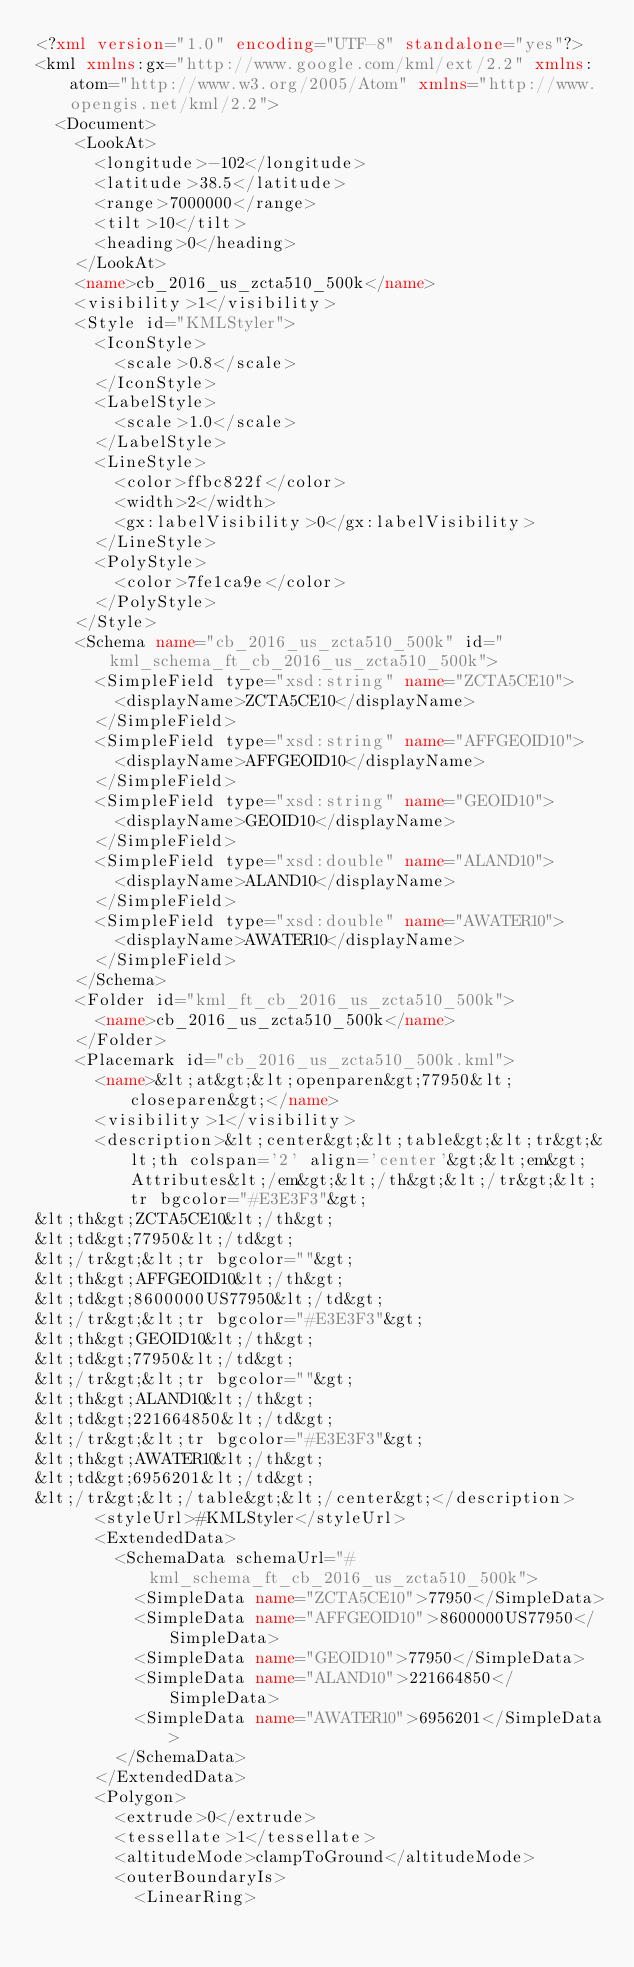Convert code to text. <code><loc_0><loc_0><loc_500><loc_500><_XML_><?xml version="1.0" encoding="UTF-8" standalone="yes"?>
<kml xmlns:gx="http://www.google.com/kml/ext/2.2" xmlns:atom="http://www.w3.org/2005/Atom" xmlns="http://www.opengis.net/kml/2.2">
  <Document>
    <LookAt>
      <longitude>-102</longitude>
      <latitude>38.5</latitude>
      <range>7000000</range>
      <tilt>10</tilt>
      <heading>0</heading>
    </LookAt>
    <name>cb_2016_us_zcta510_500k</name>
    <visibility>1</visibility>
    <Style id="KMLStyler">
      <IconStyle>
        <scale>0.8</scale>
      </IconStyle>
      <LabelStyle>
        <scale>1.0</scale>
      </LabelStyle>
      <LineStyle>
        <color>ffbc822f</color>
        <width>2</width>
        <gx:labelVisibility>0</gx:labelVisibility>
      </LineStyle>
      <PolyStyle>
        <color>7fe1ca9e</color>
      </PolyStyle>
    </Style>
    <Schema name="cb_2016_us_zcta510_500k" id="kml_schema_ft_cb_2016_us_zcta510_500k">
      <SimpleField type="xsd:string" name="ZCTA5CE10">
        <displayName>ZCTA5CE10</displayName>
      </SimpleField>
      <SimpleField type="xsd:string" name="AFFGEOID10">
        <displayName>AFFGEOID10</displayName>
      </SimpleField>
      <SimpleField type="xsd:string" name="GEOID10">
        <displayName>GEOID10</displayName>
      </SimpleField>
      <SimpleField type="xsd:double" name="ALAND10">
        <displayName>ALAND10</displayName>
      </SimpleField>
      <SimpleField type="xsd:double" name="AWATER10">
        <displayName>AWATER10</displayName>
      </SimpleField>
    </Schema>
    <Folder id="kml_ft_cb_2016_us_zcta510_500k">
      <name>cb_2016_us_zcta510_500k</name>
    </Folder>
    <Placemark id="cb_2016_us_zcta510_500k.kml">
      <name>&lt;at&gt;&lt;openparen&gt;77950&lt;closeparen&gt;</name>
      <visibility>1</visibility>
      <description>&lt;center&gt;&lt;table&gt;&lt;tr&gt;&lt;th colspan='2' align='center'&gt;&lt;em&gt;Attributes&lt;/em&gt;&lt;/th&gt;&lt;/tr&gt;&lt;tr bgcolor="#E3E3F3"&gt;
&lt;th&gt;ZCTA5CE10&lt;/th&gt;
&lt;td&gt;77950&lt;/td&gt;
&lt;/tr&gt;&lt;tr bgcolor=""&gt;
&lt;th&gt;AFFGEOID10&lt;/th&gt;
&lt;td&gt;8600000US77950&lt;/td&gt;
&lt;/tr&gt;&lt;tr bgcolor="#E3E3F3"&gt;
&lt;th&gt;GEOID10&lt;/th&gt;
&lt;td&gt;77950&lt;/td&gt;
&lt;/tr&gt;&lt;tr bgcolor=""&gt;
&lt;th&gt;ALAND10&lt;/th&gt;
&lt;td&gt;221664850&lt;/td&gt;
&lt;/tr&gt;&lt;tr bgcolor="#E3E3F3"&gt;
&lt;th&gt;AWATER10&lt;/th&gt;
&lt;td&gt;6956201&lt;/td&gt;
&lt;/tr&gt;&lt;/table&gt;&lt;/center&gt;</description>
      <styleUrl>#KMLStyler</styleUrl>
      <ExtendedData>
        <SchemaData schemaUrl="#kml_schema_ft_cb_2016_us_zcta510_500k">
          <SimpleData name="ZCTA5CE10">77950</SimpleData>
          <SimpleData name="AFFGEOID10">8600000US77950</SimpleData>
          <SimpleData name="GEOID10">77950</SimpleData>
          <SimpleData name="ALAND10">221664850</SimpleData>
          <SimpleData name="AWATER10">6956201</SimpleData>
        </SchemaData>
      </ExtendedData>
      <Polygon>
        <extrude>0</extrude>
        <tessellate>1</tessellate>
        <altitudeMode>clampToGround</altitudeMode>
        <outerBoundaryIs>
          <LinearRing></code> 